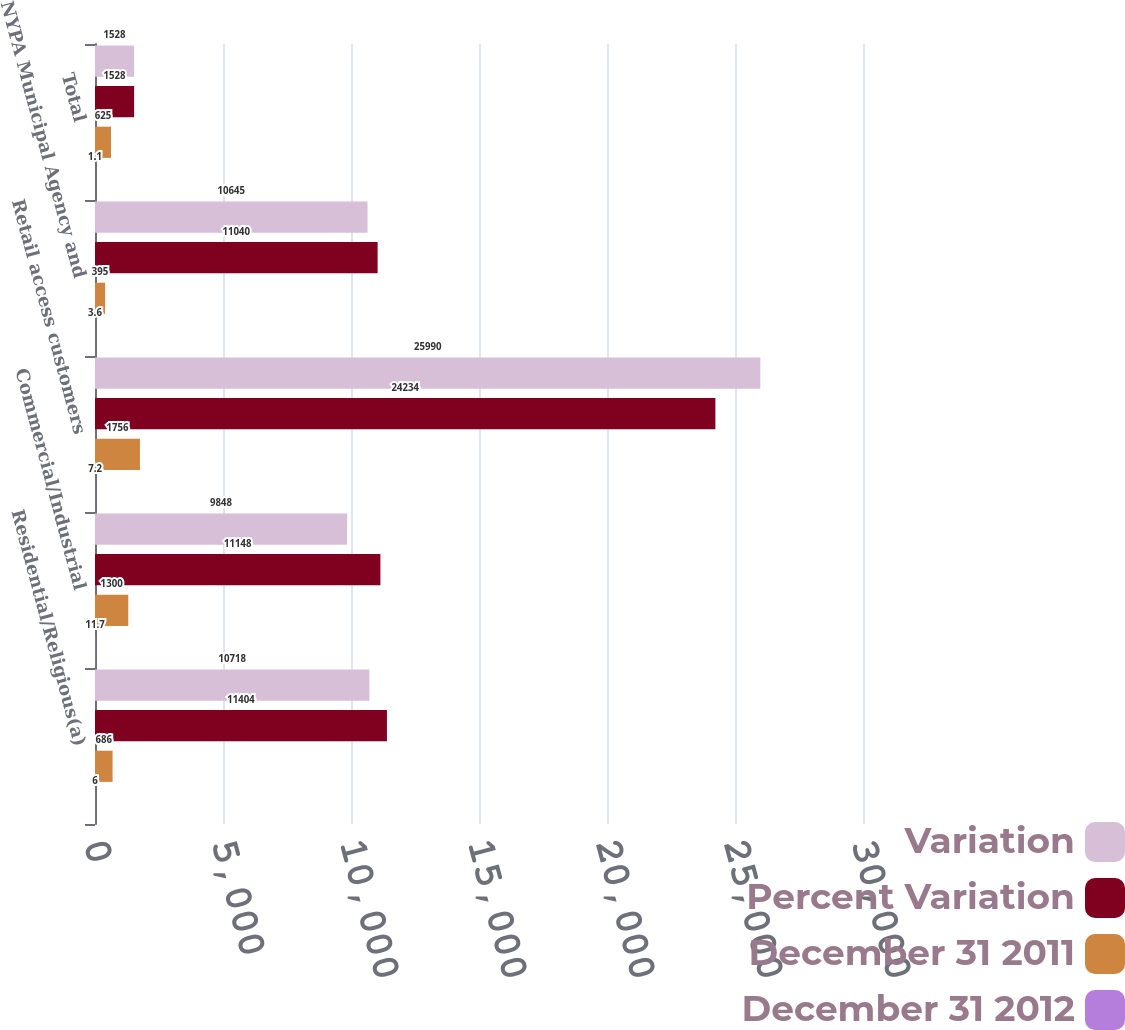Convert chart to OTSL. <chart><loc_0><loc_0><loc_500><loc_500><stacked_bar_chart><ecel><fcel>Residential/Religious(a)<fcel>Commercial/Industrial<fcel>Retail access customers<fcel>NYPA Municipal Agency and<fcel>Total<nl><fcel>Variation<fcel>10718<fcel>9848<fcel>25990<fcel>10645<fcel>1528<nl><fcel>Percent Variation<fcel>11404<fcel>11148<fcel>24234<fcel>11040<fcel>1528<nl><fcel>December 31 2011<fcel>686<fcel>1300<fcel>1756<fcel>395<fcel>625<nl><fcel>December 31 2012<fcel>6<fcel>11.7<fcel>7.2<fcel>3.6<fcel>1.1<nl></chart> 